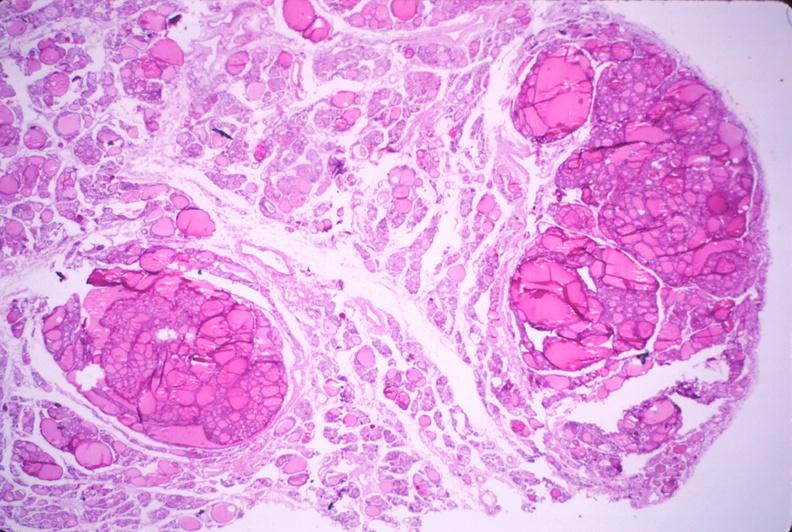what does this image show?
Answer the question using a single word or phrase. Thyroid 